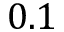<formula> <loc_0><loc_0><loc_500><loc_500>0 . 1</formula> 